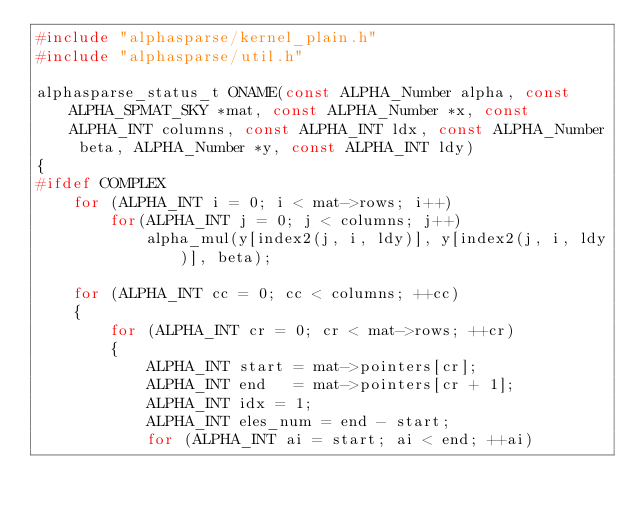Convert code to text. <code><loc_0><loc_0><loc_500><loc_500><_C_>#include "alphasparse/kernel_plain.h"
#include "alphasparse/util.h"

alphasparse_status_t ONAME(const ALPHA_Number alpha, const ALPHA_SPMAT_SKY *mat, const ALPHA_Number *x, const ALPHA_INT columns, const ALPHA_INT ldx, const ALPHA_Number beta, ALPHA_Number *y, const ALPHA_INT ldy)
{
#ifdef COMPLEX
    for (ALPHA_INT i = 0; i < mat->rows; i++)
        for(ALPHA_INT j = 0; j < columns; j++)
            alpha_mul(y[index2(j, i, ldy)], y[index2(j, i, ldy)], beta);

    for (ALPHA_INT cc = 0; cc < columns; ++cc)
    {
        for (ALPHA_INT cr = 0; cr < mat->rows; ++cr)
        {
            ALPHA_INT start = mat->pointers[cr];
            ALPHA_INT end   = mat->pointers[cr + 1];
            ALPHA_INT idx = 1;
            ALPHA_INT eles_num = end - start;
            for (ALPHA_INT ai = start; ai < end; ++ai)</code> 